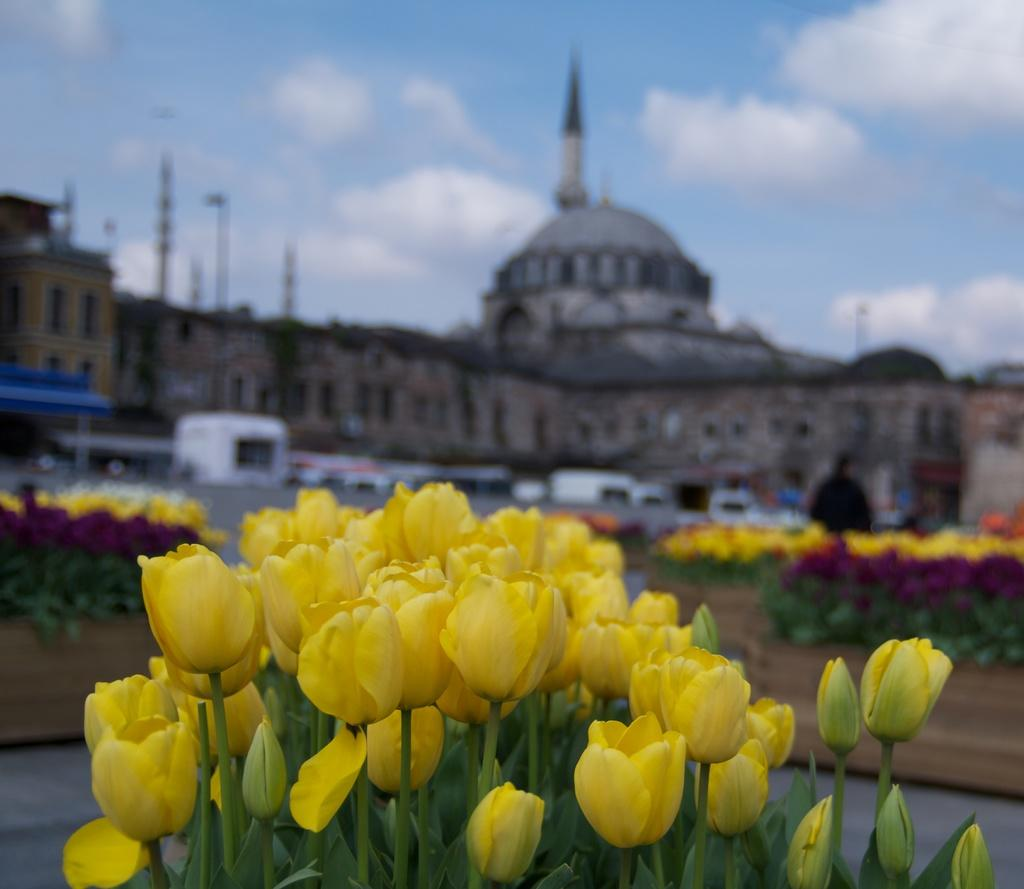What types of living organisms can be seen in the image? There are flowers and plants visible in the image. What man-made structures are present in the image? There are buildings and poles visible in the image. What type of transportation is present in the image? There are vehicles visible in the image. What part of the natural environment is visible in the image? The sky is visible in the image. What type of club does the carpenter use to work on the buildings in the image? There is no carpenter or club present in the image. What kind of rat can be seen interacting with the flowers in the image? There are no rats present in the image; it features flowers, plants, buildings, poles, vehicles, and the sky. 